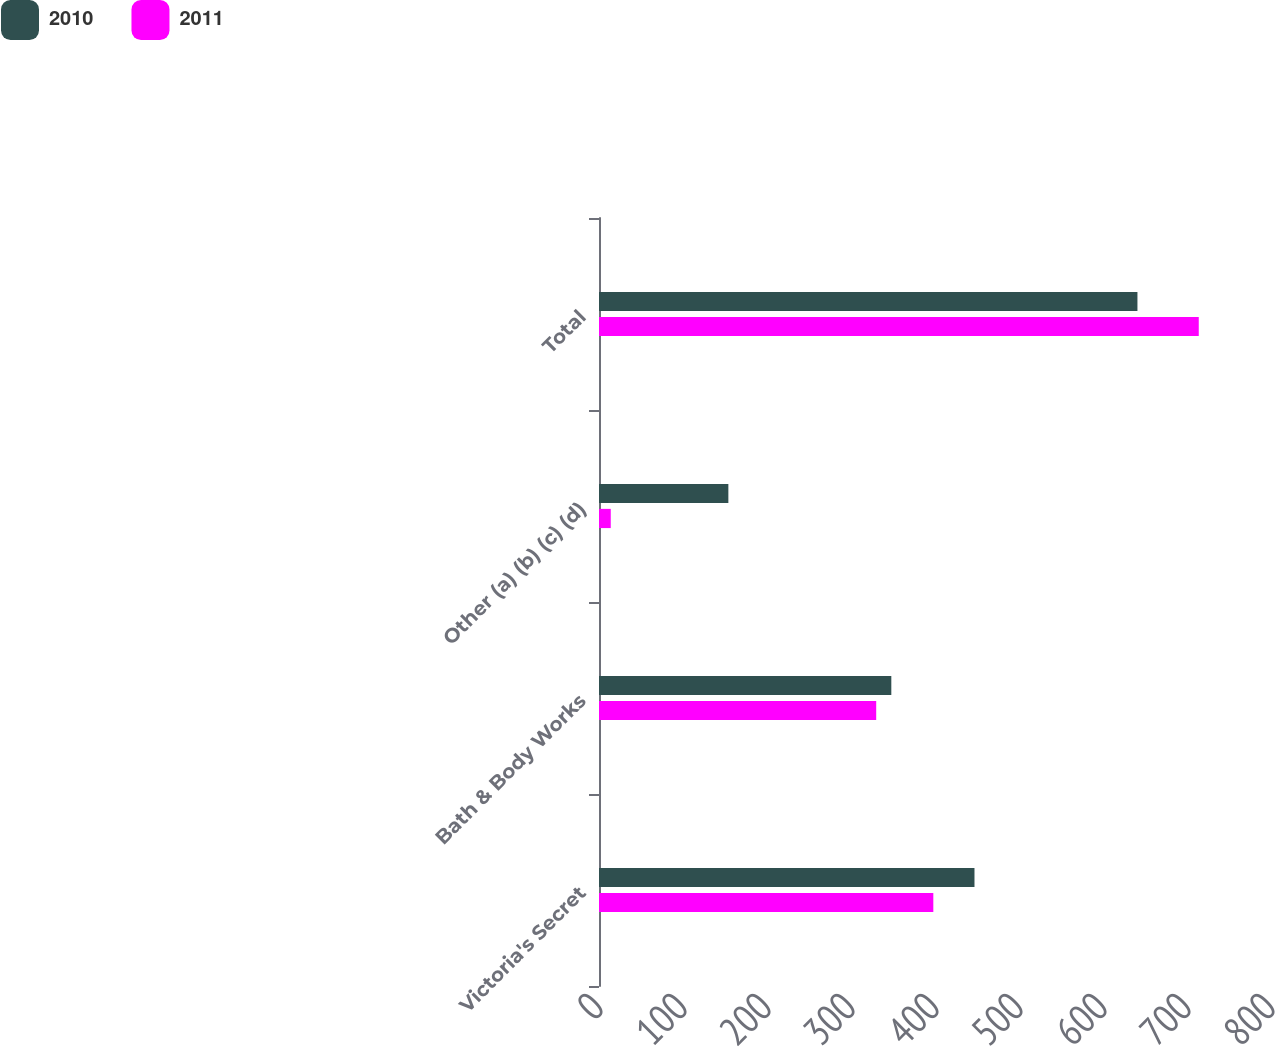Convert chart to OTSL. <chart><loc_0><loc_0><loc_500><loc_500><stacked_bar_chart><ecel><fcel>Victoria's Secret<fcel>Bath & Body Works<fcel>Other (a) (b) (c) (d)<fcel>Total<nl><fcel>2010<fcel>447<fcel>348<fcel>154<fcel>641<nl><fcel>2011<fcel>398<fcel>330<fcel>14<fcel>714<nl></chart> 